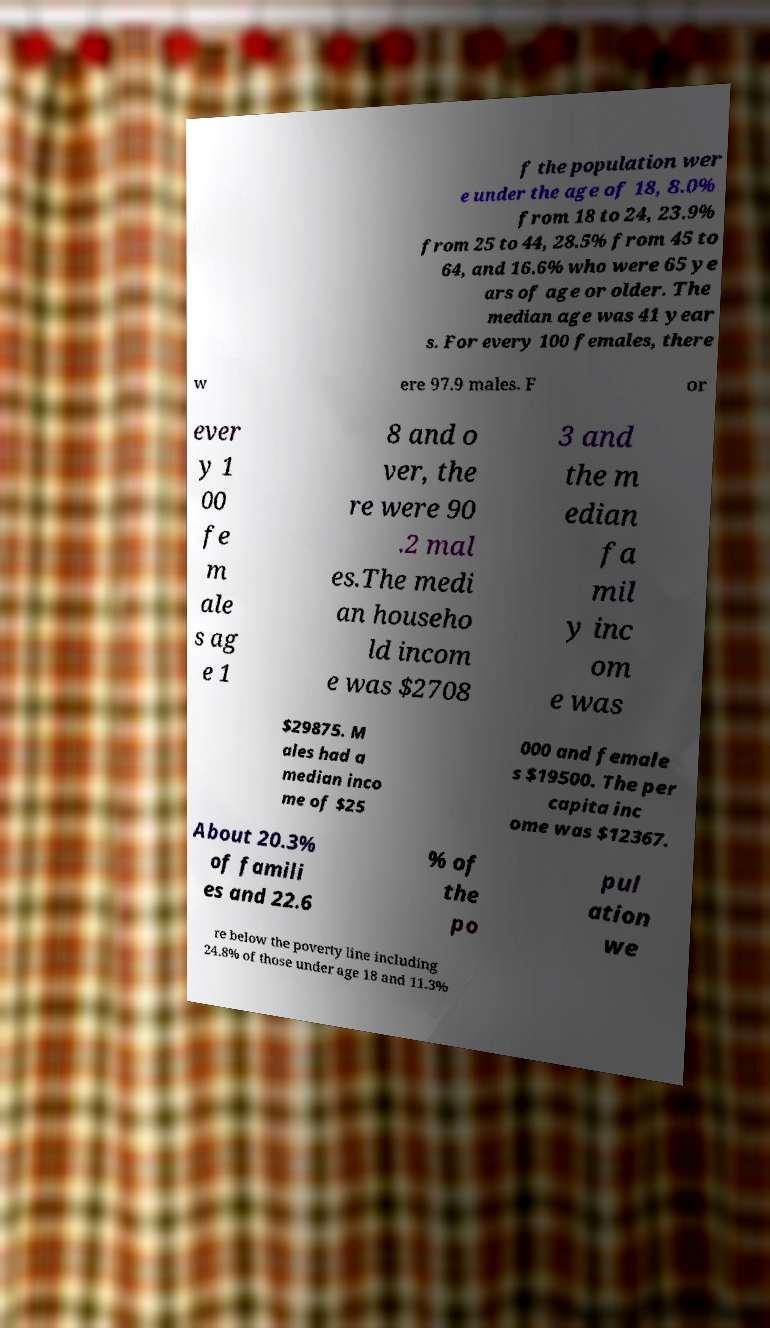Please read and relay the text visible in this image. What does it say? f the population wer e under the age of 18, 8.0% from 18 to 24, 23.9% from 25 to 44, 28.5% from 45 to 64, and 16.6% who were 65 ye ars of age or older. The median age was 41 year s. For every 100 females, there w ere 97.9 males. F or ever y 1 00 fe m ale s ag e 1 8 and o ver, the re were 90 .2 mal es.The medi an househo ld incom e was $2708 3 and the m edian fa mil y inc om e was $29875. M ales had a median inco me of $25 000 and female s $19500. The per capita inc ome was $12367. About 20.3% of famili es and 22.6 % of the po pul ation we re below the poverty line including 24.8% of those under age 18 and 11.3% 